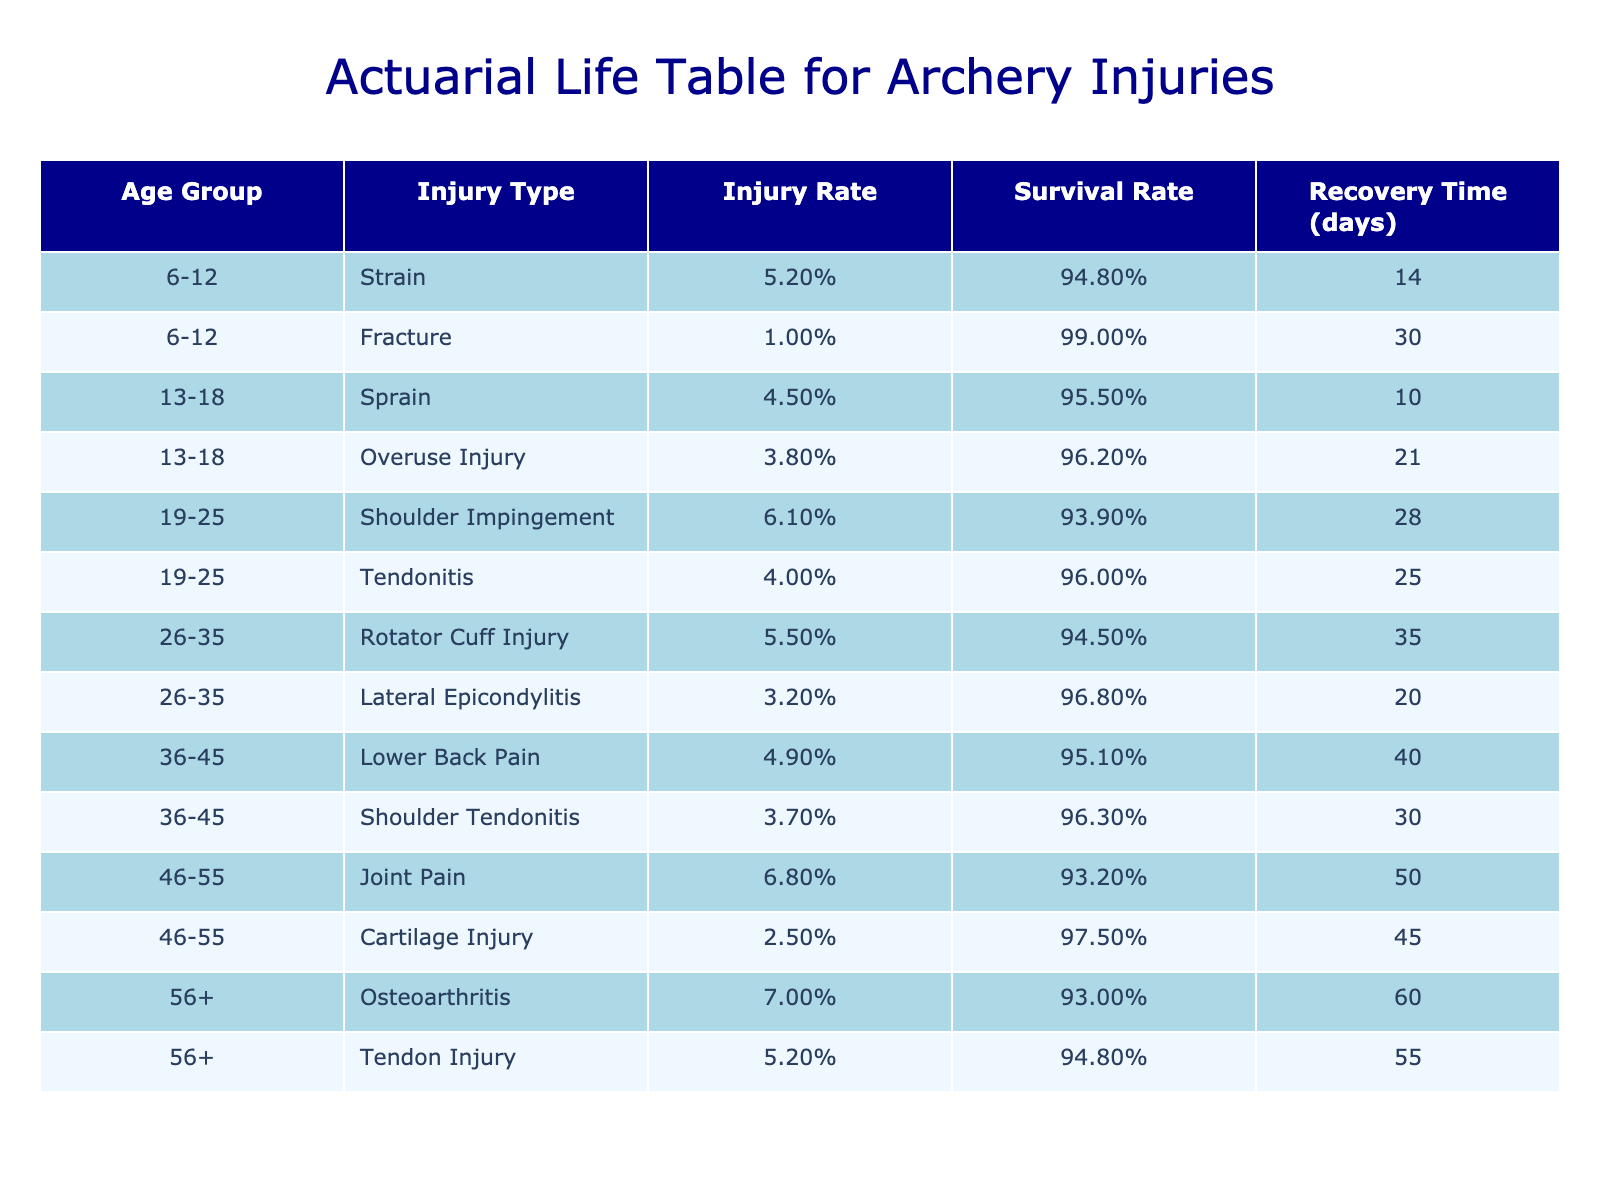What is the injury incidence rate for shoulder impingement in the age group 19-25? The table shows the row for the age group 19-25 and lists shoulder impingement under Injury Type. The corresponding Injury Incidence per 100 is directly provided as 6.1.
Answer: 6.1 Which age group has the highest average recovery time for injuries? To find the highest recovery time, we can compare the Average Recovery Time days across all age groups. The row for age group 56+ shows an Osteoarthritis recovery time of 60 days, which is higher than any other group listed.
Answer: 56+ Is the injury incidence rate for joint pain higher than that for tendonitis? The table lists Joint Pain for the age group 46-55 with an incidence rate of 6.8 per 100, while Tendonitis for the age group 19-25 has an incidence rate of 4.0 per 100. Since 6.8 is greater than 4.0, the statement is true.
Answer: Yes What is the average recovery time for all injuries in the age group 36-45? To find the average recovery time for age group 36-45, we will sum the Average Recovery Times of both types of injuries listed: 40 (Lower Back Pain) + 30 (Shoulder Tendonitis) = 70. We then divide that sum by the number of injuries (2), resulting in an average recovery time of 70/2 = 35 days.
Answer: 35 Are overuse injuries more common than strains in the age group 13-18? The table shows that Overuse Injury has an incidence rate of 3.8 per 100, while Strain is not listed in this age group, which stands for an incidence of 0. As 3.8 is greater than 0, Overuse Injuries are indeed more common than Strains in this age group.
Answer: Yes What is the total injury incidence rate for the age group 6-12? For the age group 6-12, we sum the injury incidences of both injuries listed: 5.2 (Strain) + 1.0 (Fracture) = 6.2 per 100, which gives us the total injury incidence rate for this age group.
Answer: 6.2 Which injury has the shortest average recovery time in the age group 19-25? In the age group 19-25, the table lists two injuries: Shoulder Impingement with a recovery time of 28 days and Tendonitis with a recovery time of 25 days. Since 25 days is the lesser value, it indicates that Tendonitis has the shortest average recovery time in this group.
Answer: Tendonitis How does the injury incidence rate for fractures compare to that of cartilage injuries in their respective age groups? For Fractures in the age group 6-12, the incidence rate is 1.0, while for Cartilage Injuries in the age group 46-55, it is 2.5. Since 2.5 is higher than 1.0, we see that the incidence rate for Cartilage Injuries is higher than that for Fractures.
Answer: Cartilage Injuries have a higher incidence rate 